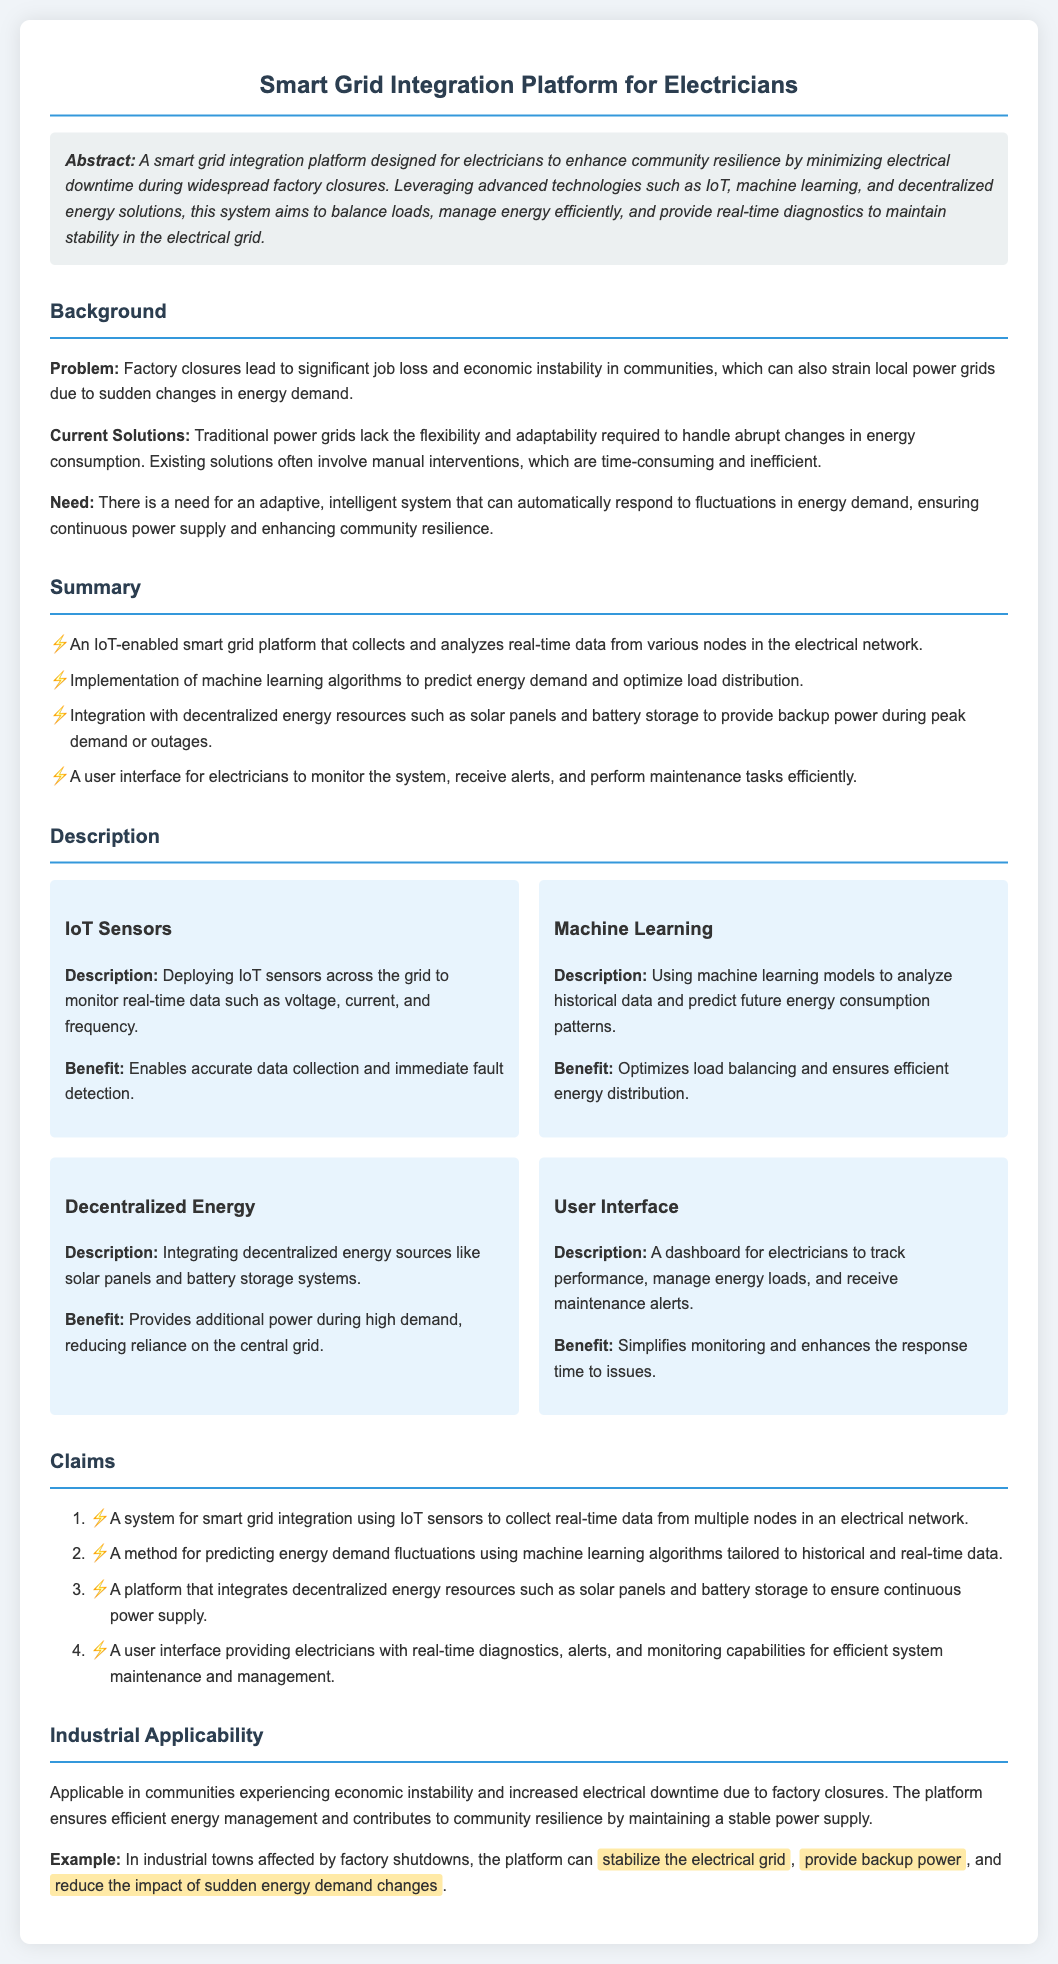What is the main aim of the platform? The main aim of the platform is to enhance community resilience by minimizing electrical downtime during widespread factory closures.
Answer: Enhance community resilience What technology is used for predicting energy demand? Machine learning algorithms are used to predict energy demand and optimize load distribution.
Answer: Machine learning algorithms What are the IoT sensors monitoring? IoT sensors are monitoring real-time data such as voltage, current, and frequency.
Answer: Voltage, current, and frequency How does the platform support backup power during peak demand? The platform integrates decentralized energy sources such as solar panels and battery storage.
Answer: Solar panels and battery storage What is an example of the platform's applicability? The platform can stabilize the electrical grid and provide backup power in industrial towns affected by factory shutdowns.
Answer: Stabilize the electrical grid What does the user interface provide for electricians? The user interface provides real-time diagnostics, alerts, and monitoring capabilities.
Answer: Real-time diagnostics, alerts How many claims are listed in the document? There are four claims listed in the document.
Answer: Four claims What is the background problem addressed in the document? The problem is significant job loss and economic instability in communities due to factory closures.
Answer: Job loss and economic instability What benefit does machine learning provide in the platform? Machine learning optimizes load balancing and ensures efficient energy distribution.
Answer: Optimizes load balancing 